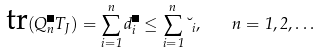Convert formula to latex. <formula><loc_0><loc_0><loc_500><loc_500>\text {tr} ( Q _ { n } ^ { \psi } T _ { J } ) = \sum _ { i = 1 } ^ { n } d _ { i } ^ { \psi } \leq \sum _ { i = 1 } ^ { n } \lambda _ { i } , \quad n = 1 , 2 , \dots</formula> 